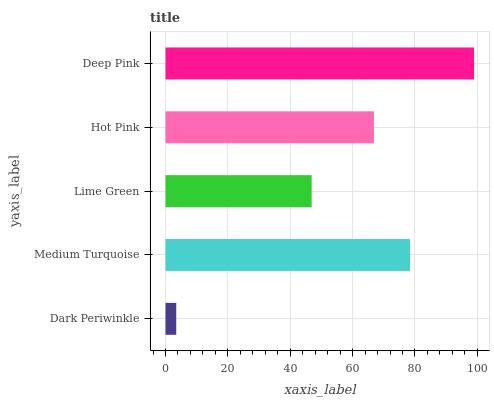Is Dark Periwinkle the minimum?
Answer yes or no. Yes. Is Deep Pink the maximum?
Answer yes or no. Yes. Is Medium Turquoise the minimum?
Answer yes or no. No. Is Medium Turquoise the maximum?
Answer yes or no. No. Is Medium Turquoise greater than Dark Periwinkle?
Answer yes or no. Yes. Is Dark Periwinkle less than Medium Turquoise?
Answer yes or no. Yes. Is Dark Periwinkle greater than Medium Turquoise?
Answer yes or no. No. Is Medium Turquoise less than Dark Periwinkle?
Answer yes or no. No. Is Hot Pink the high median?
Answer yes or no. Yes. Is Hot Pink the low median?
Answer yes or no. Yes. Is Dark Periwinkle the high median?
Answer yes or no. No. Is Dark Periwinkle the low median?
Answer yes or no. No. 